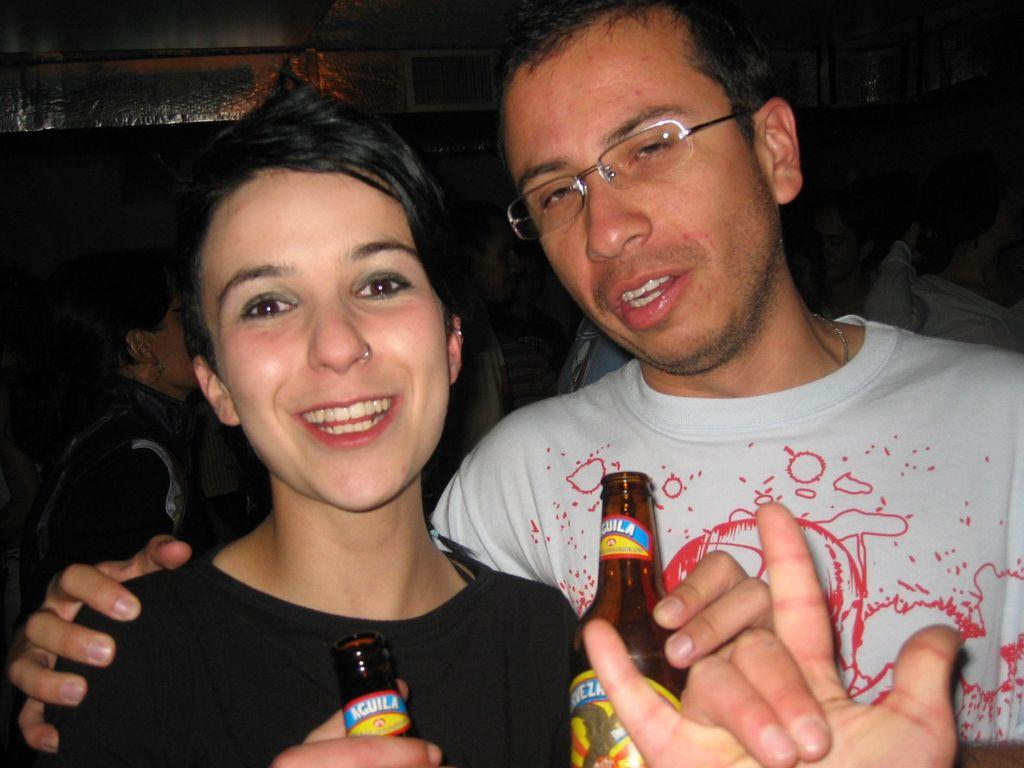What are the two people in the image holding? The woman and the man are holding a wine bottle. Can you describe the two people in the image? There is a woman and a man in the image. What is visible in the background of the image? There are people in the background of the image. What type of table is visible in the image? There is no table present in the image. What route are the people in the image following? There is no indication of a specific route being followed in the image. 